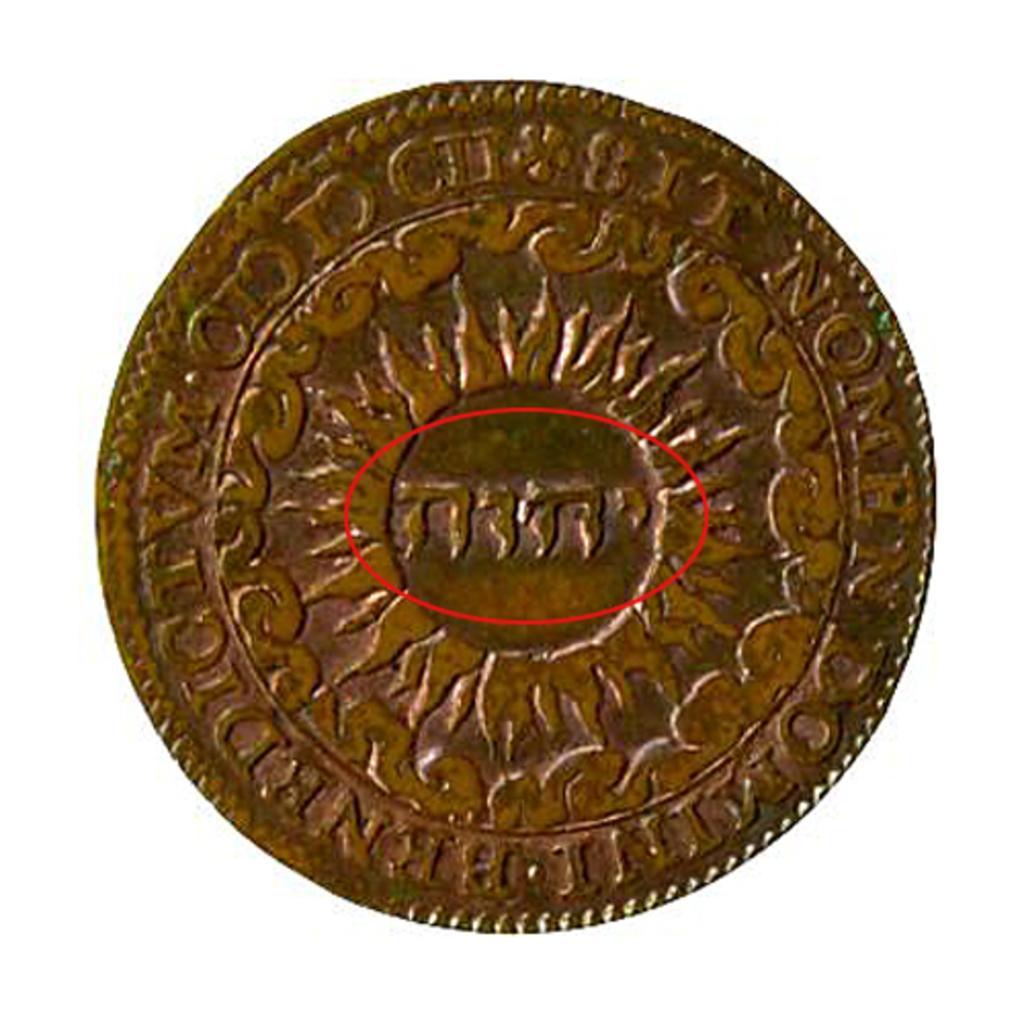In one or two sentences, can you explain what this image depicts? In this image we can see a coin with an emblem. On that something is written. In the background it is white. 